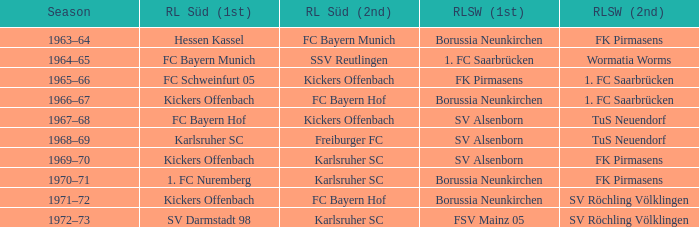Who was RL Süd (1st) when FK Pirmasens was RL Südwest (1st)? FC Schweinfurt 05. 